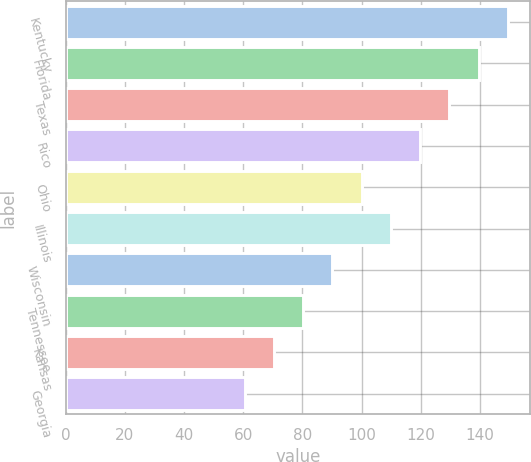Convert chart. <chart><loc_0><loc_0><loc_500><loc_500><bar_chart><fcel>Kentucky<fcel>Florida<fcel>Texas<fcel>Rico<fcel>Ohio<fcel>Illinois<fcel>Wisconsin<fcel>Tennessee<fcel>Kansas<fcel>Georgia<nl><fcel>149.45<fcel>139.56<fcel>129.67<fcel>119.78<fcel>100<fcel>109.89<fcel>90.11<fcel>80.22<fcel>70.33<fcel>60.44<nl></chart> 